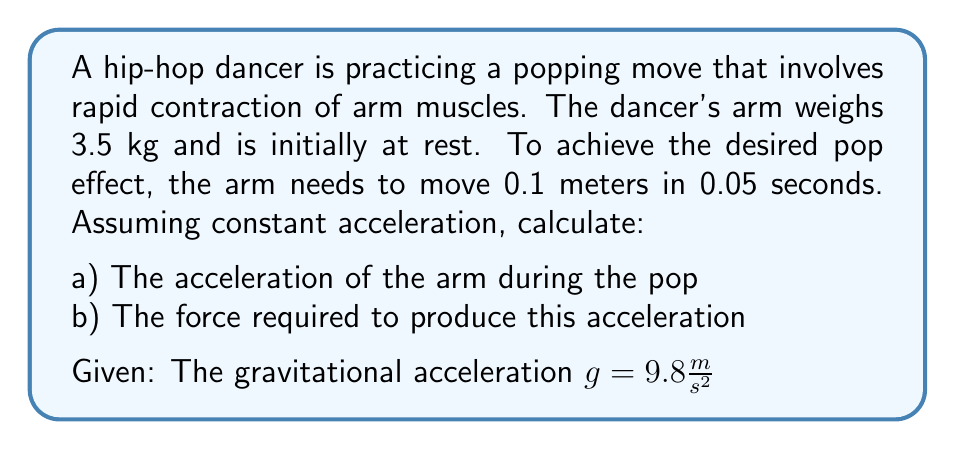Teach me how to tackle this problem. Let's approach this problem step-by-step:

a) To calculate the acceleration, we can use the equation of motion:

$$ s = ut + \frac{1}{2}at^2 $$

Where:
$s$ = displacement (0.1 m)
$u$ = initial velocity (0 m/s, as the arm starts from rest)
$t$ = time (0.05 s)
$a$ = acceleration (what we're solving for)

Substituting the values:

$$ 0.1 = 0 \cdot 0.05 + \frac{1}{2}a(0.05)^2 $$

Simplifying:

$$ 0.1 = \frac{1}{2}a(0.0025) $$
$$ 0.1 = 0.00125a $$
$$ a = \frac{0.1}{0.00125} = 80 \frac{m}{s^2} $$

b) To calculate the force required, we use Newton's Second Law:

$$ F = ma $$

Where:
$m$ = mass of the arm (3.5 kg)
$a$ = acceleration we just calculated (80 m/s²)

However, we also need to account for the force of gravity acting on the arm. The total force will be the vector sum of the force required for acceleration and the force counteracting gravity.

Force for acceleration:
$$ F_a = ma = 3.5 \cdot 80 = 280 \text{ N} $$

Force to counteract gravity:
$$ F_g = mg = 3.5 \cdot 9.8 = 34.3 \text{ N} $$

The total force required is the vector sum of these forces. Assuming the pop is in the upward direction:

$$ F_{total} = F_a + F_g = 280 + 34.3 = 314.3 \text{ N} $$
Answer: a) The acceleration of the arm during the pop is $80 \frac{m}{s^2}$
b) The total force required to produce this acceleration is $314.3 \text{ N}$ 